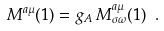Convert formula to latex. <formula><loc_0><loc_0><loc_500><loc_500>M ^ { a \mu } ( 1 ) = g _ { A } \, M ^ { a \mu } _ { \sigma \omega } ( 1 ) \ .</formula> 